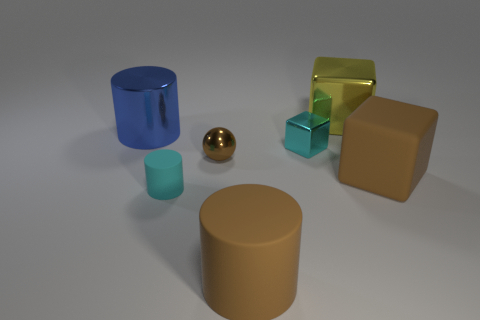How many balls are tiny matte things or blue shiny objects?
Ensure brevity in your answer.  0. The small shiny sphere is what color?
Ensure brevity in your answer.  Brown. There is a brown thing that is in front of the cyan cylinder; is it the same size as the matte cylinder on the left side of the brown metal ball?
Ensure brevity in your answer.  No. Are there fewer big green shiny blocks than balls?
Your answer should be compact. Yes. There is a tiny brown metallic object; what number of large blue cylinders are on the right side of it?
Your answer should be very brief. 0. What material is the yellow block?
Make the answer very short. Metal. Is the metallic ball the same color as the large rubber cylinder?
Offer a very short reply. Yes. Is the number of big blue things that are right of the tiny ball less than the number of tiny blocks?
Your answer should be compact. Yes. There is a big metal thing that is on the right side of the small ball; what is its color?
Provide a short and direct response. Yellow. The big blue metallic object is what shape?
Make the answer very short. Cylinder. 